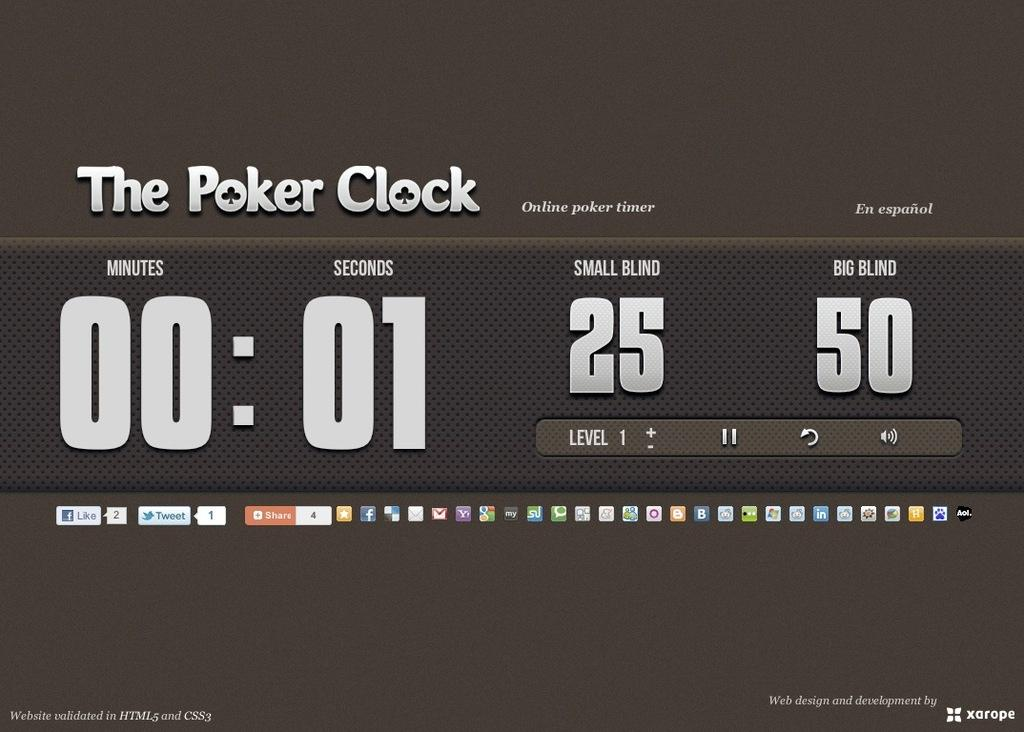<image>
Share a concise interpretation of the image provided. A screenshot of the Poker Clock with 1 second left on the timer. 